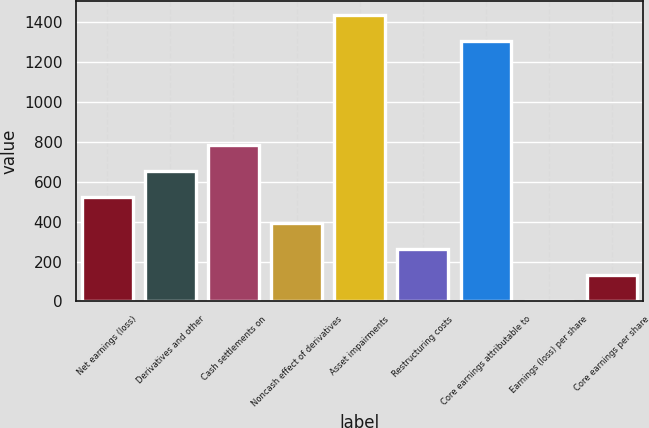Convert chart to OTSL. <chart><loc_0><loc_0><loc_500><loc_500><bar_chart><fcel>Net earnings (loss)<fcel>Derivatives and other<fcel>Cash settlements on<fcel>Noncash effect of derivatives<fcel>Asset impairments<fcel>Restructuring costs<fcel>Core earnings attributable to<fcel>Earnings (loss) per share<fcel>Core earnings per share<nl><fcel>523.47<fcel>654.22<fcel>784.97<fcel>392.72<fcel>1435.75<fcel>261.97<fcel>1305<fcel>0.47<fcel>131.22<nl></chart> 